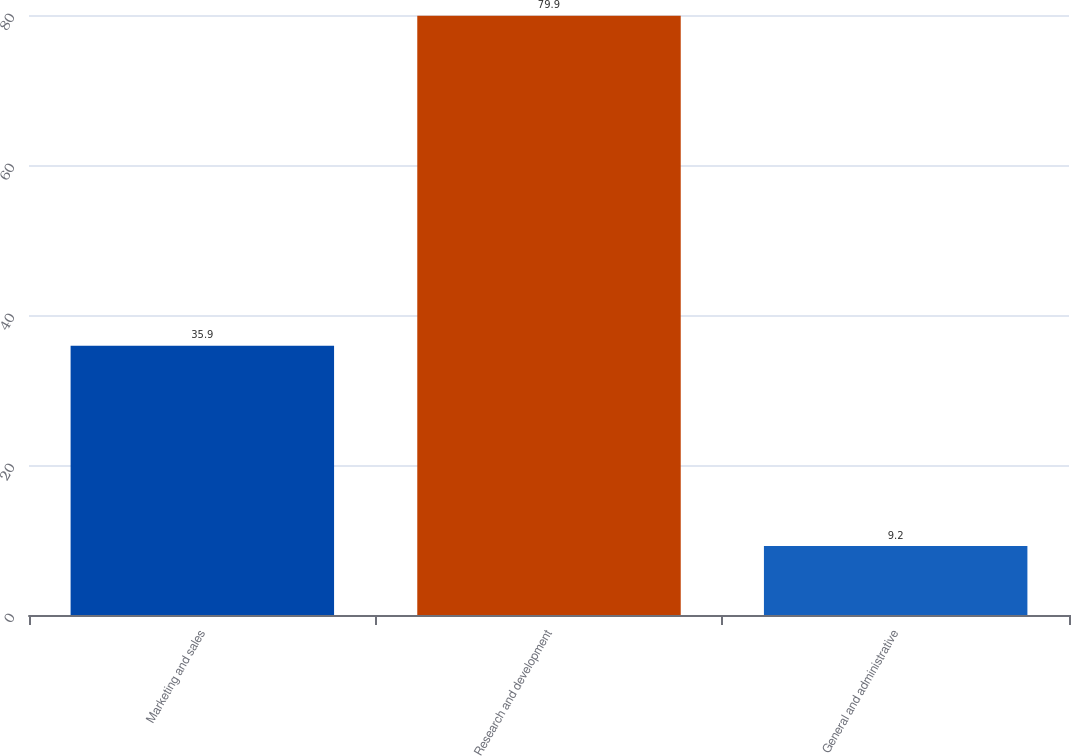Convert chart. <chart><loc_0><loc_0><loc_500><loc_500><bar_chart><fcel>Marketing and sales<fcel>Research and development<fcel>General and administrative<nl><fcel>35.9<fcel>79.9<fcel>9.2<nl></chart> 